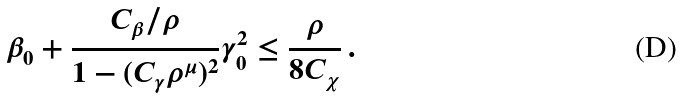<formula> <loc_0><loc_0><loc_500><loc_500>\beta _ { 0 } + \frac { C _ { \beta } / \rho } { 1 - ( C _ { \gamma } \rho ^ { \mu } ) ^ { 2 } } \gamma _ { 0 } ^ { 2 } \leq \frac { \rho } { 8 C _ { \chi } } \, .</formula> 